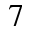Convert formula to latex. <formula><loc_0><loc_0><loc_500><loc_500>7</formula> 